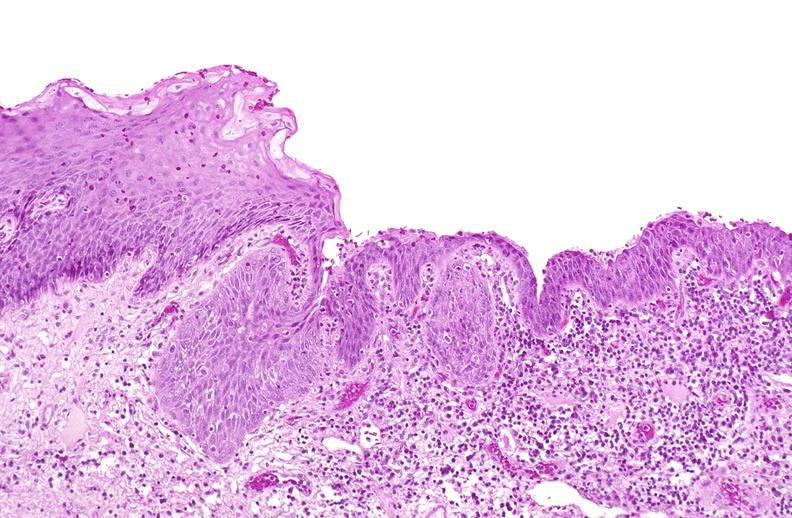where is this?
Answer the question using a single word or phrase. Urinary 